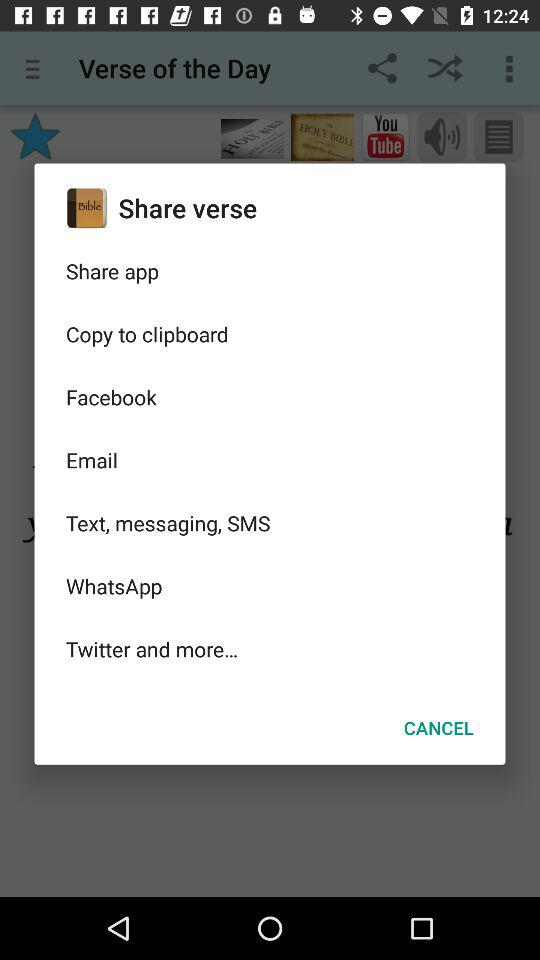How many items are in the share menu?
Answer the question using a single word or phrase. 8 